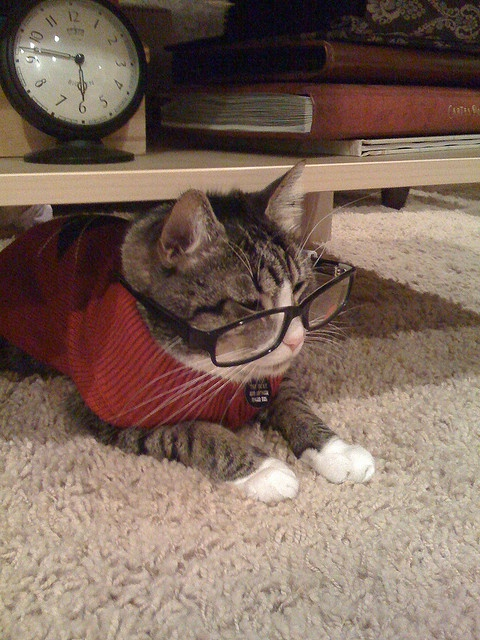Describe the objects in this image and their specific colors. I can see cat in black, maroon, and gray tones, book in black, maroon, and gray tones, clock in black, darkgray, and gray tones, and book in black, darkgray, and gray tones in this image. 